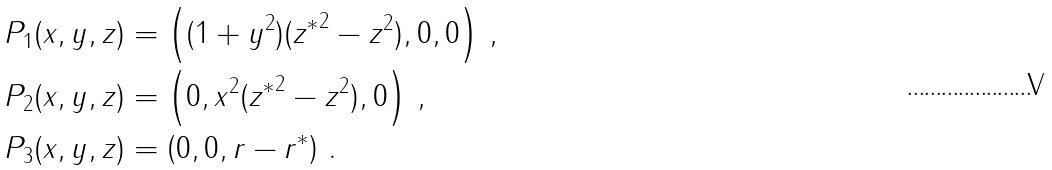<formula> <loc_0><loc_0><loc_500><loc_500>P _ { 1 } ( x , y , z ) & = \left ( ( 1 + y ^ { 2 } ) ( { z ^ { * } } ^ { 2 } - z ^ { 2 } ) , 0 , 0 \right ) \, , \\ P _ { 2 } ( x , y , z ) & = \left ( 0 , x ^ { 2 } ( { z ^ { * } } ^ { 2 } - z ^ { 2 } ) , 0 \right ) \, , \\ P _ { 3 } ( x , y , z ) & = \left ( 0 , 0 , r - r ^ { * } \right ) \, .</formula> 